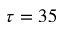<formula> <loc_0><loc_0><loc_500><loc_500>\tau = 3 5</formula> 